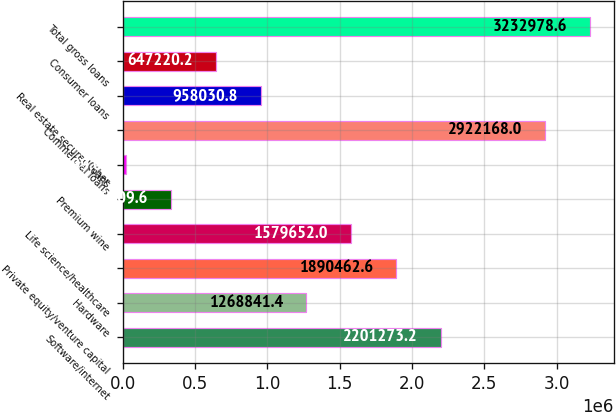Convert chart. <chart><loc_0><loc_0><loc_500><loc_500><bar_chart><fcel>Software/internet<fcel>Hardware<fcel>Private equity/venture capital<fcel>Life science/healthcare<fcel>Premium wine<fcel>Other<fcel>Commercial loans<fcel>Real estate secured loans<fcel>Consumer loans<fcel>Total gross loans<nl><fcel>2.20127e+06<fcel>1.26884e+06<fcel>1.89046e+06<fcel>1.57965e+06<fcel>336410<fcel>25599<fcel>2.92217e+06<fcel>958031<fcel>647220<fcel>3.23298e+06<nl></chart> 